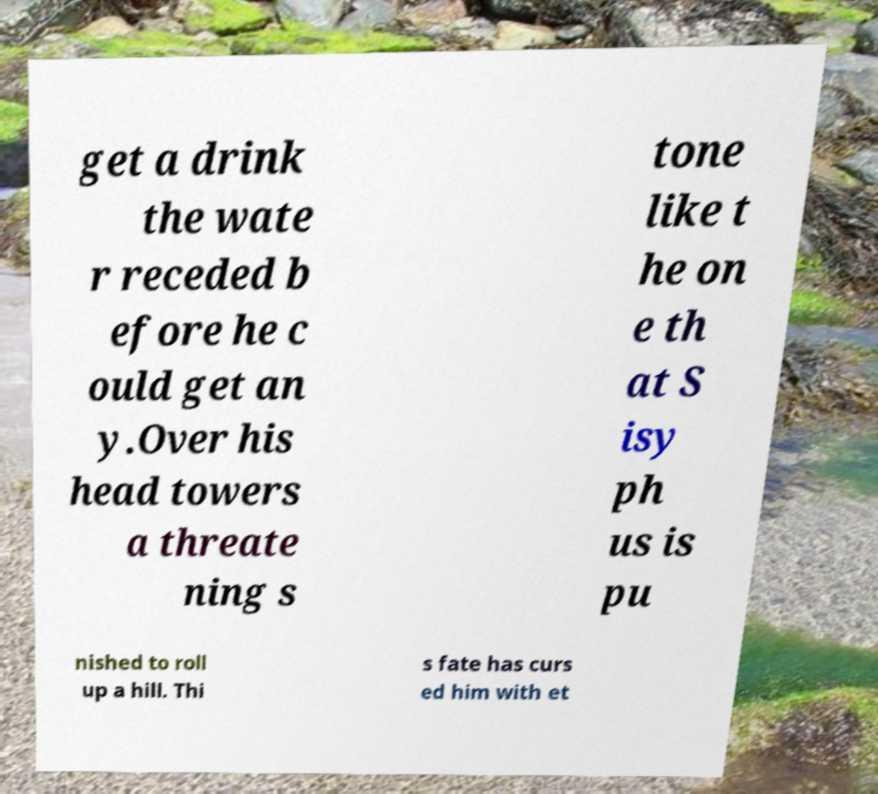I need the written content from this picture converted into text. Can you do that? get a drink the wate r receded b efore he c ould get an y.Over his head towers a threate ning s tone like t he on e th at S isy ph us is pu nished to roll up a hill. Thi s fate has curs ed him with et 